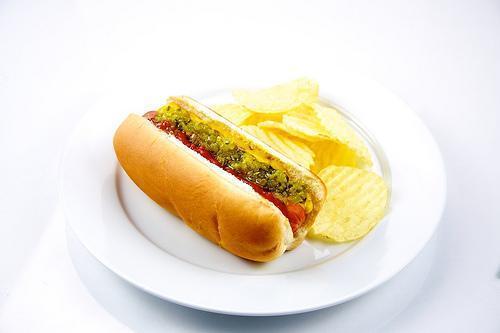How many hot dogs are in the picture?
Give a very brief answer. 1. 